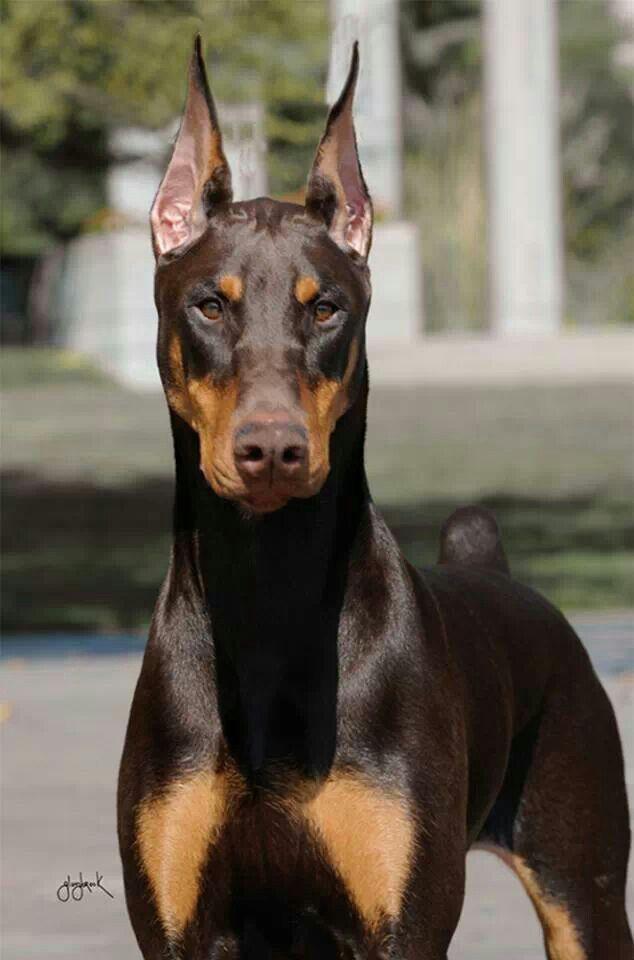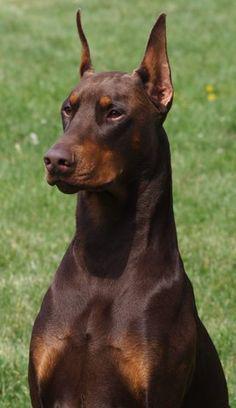The first image is the image on the left, the second image is the image on the right. Assess this claim about the two images: "There are only 2 dogs.". Correct or not? Answer yes or no. Yes. The first image is the image on the left, the second image is the image on the right. Analyze the images presented: Is the assertion "A dog is laying down." valid? Answer yes or no. No. 